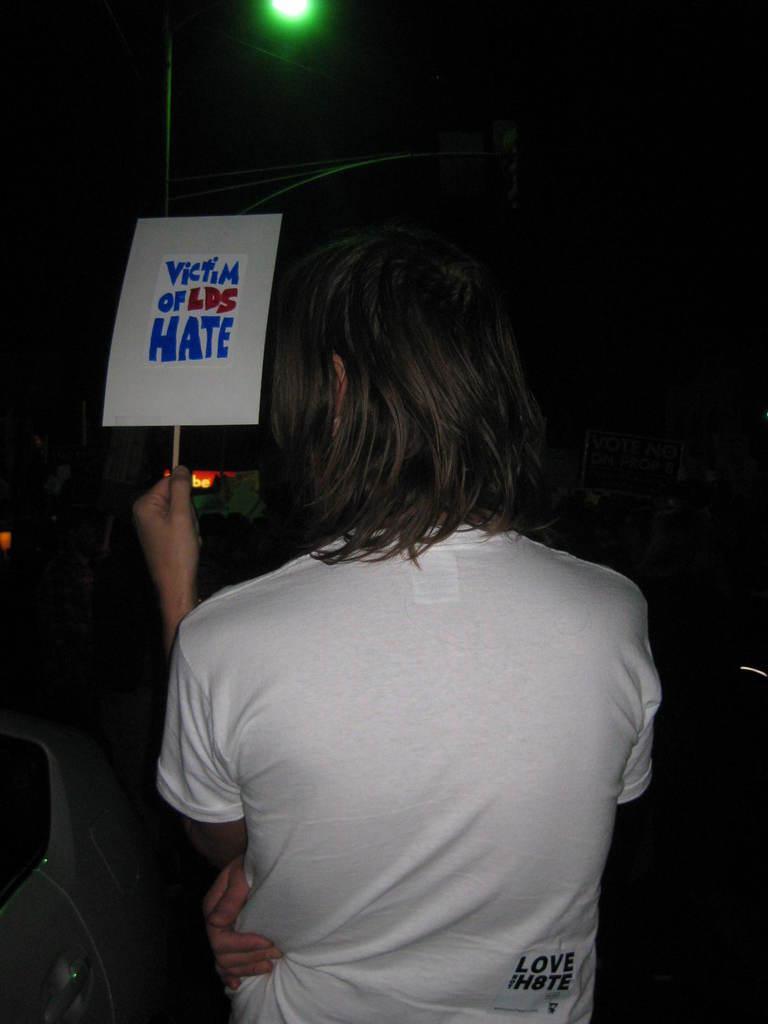Can you describe this image briefly? In this picture we can see a person holding a poster and in front of this person we can see the light, some objects and in the background it is dark. 